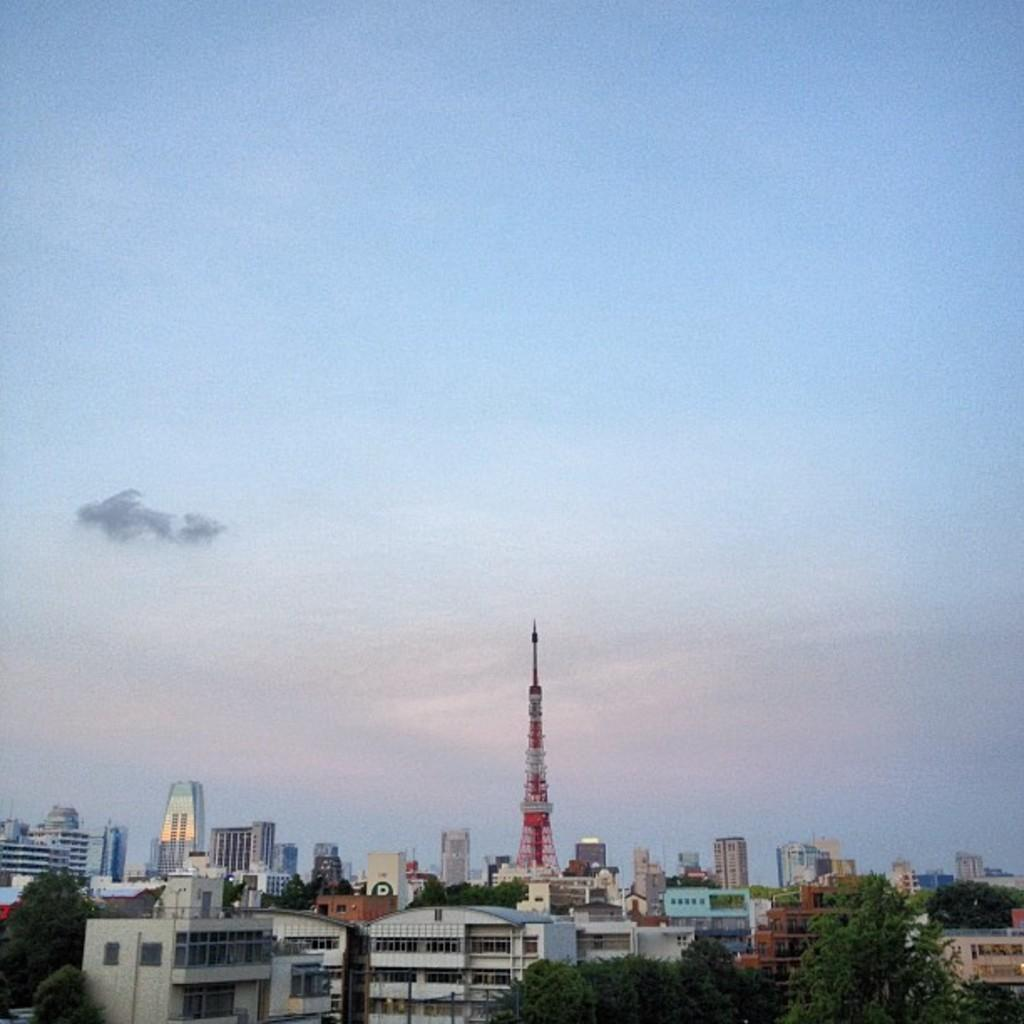What type of natural elements can be seen in the image? There are trees in the image. What type of man-made structures can be seen in the image? There are buildings in the image. Where are the trees and buildings located in the image? The bottom of the image contains trees and buildings. What is visible in the background of the image? The sky is visible in the background of the image. What color is the sky in the image? The sky is blue in the image. How many cans of paint are used to create the note on the tree in the image? There is no note or paint visible on the trees in the image. What type of visitor can be seen interacting with the buildings in the image? There are no visitors present in the image; only trees, buildings, and the sky are visible. 